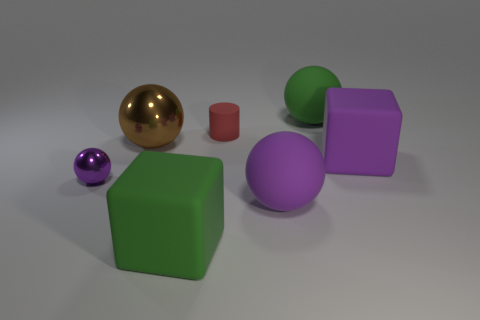Do the purple object that is left of the brown thing and the small red rubber cylinder have the same size?
Provide a short and direct response. Yes. The purple shiny object that is the same shape as the large brown object is what size?
Your answer should be very brief. Small. What material is the green sphere that is the same size as the brown ball?
Your response must be concise. Rubber. There is another big purple object that is the same shape as the big metal object; what is it made of?
Provide a short and direct response. Rubber. How many other things are there of the same size as the matte cylinder?
Keep it short and to the point. 1. There is a block that is the same color as the small shiny object; what is its size?
Give a very brief answer. Large. What number of matte cubes have the same color as the small shiny ball?
Provide a succinct answer. 1. The red matte object is what shape?
Give a very brief answer. Cylinder. The ball that is both on the right side of the large brown thing and behind the big purple rubber ball is what color?
Your response must be concise. Green. What material is the tiny purple ball?
Offer a very short reply. Metal. 